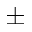<formula> <loc_0><loc_0><loc_500><loc_500>\pm</formula> 